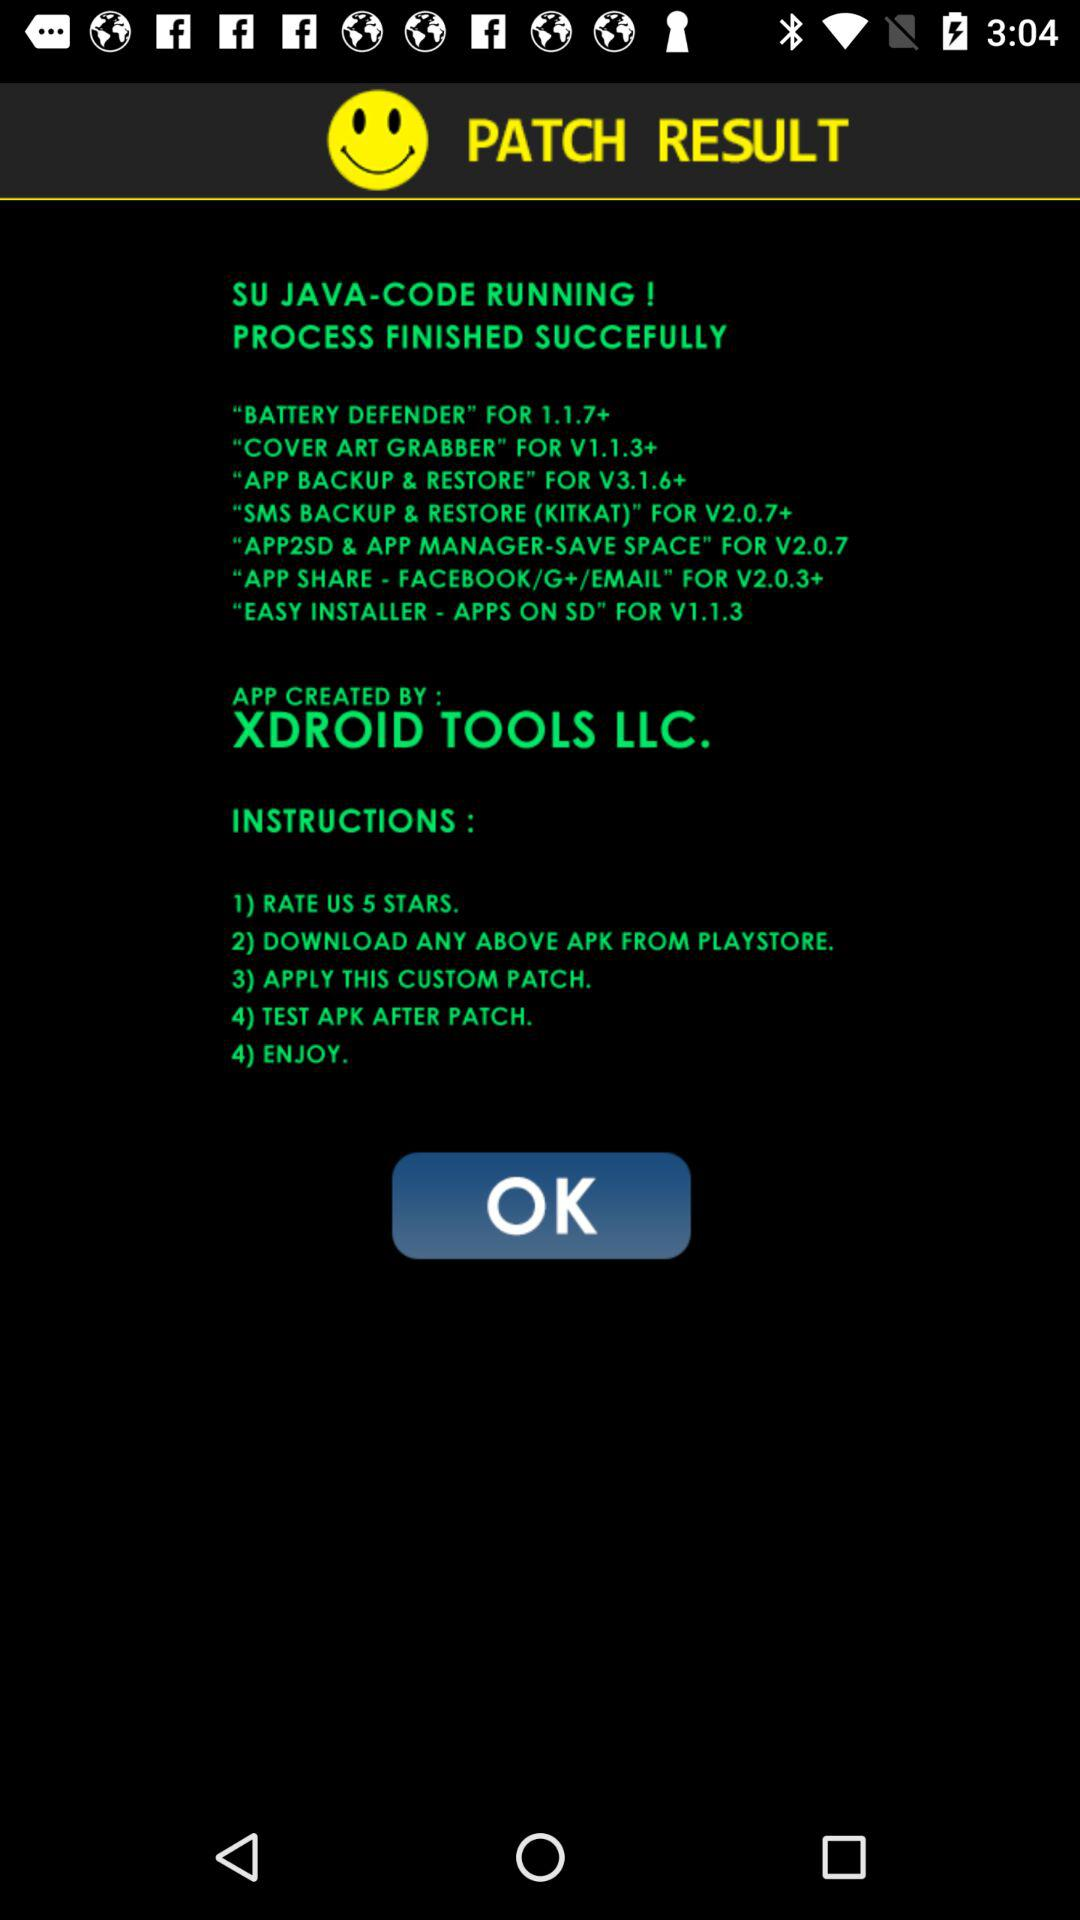How many steps are in the instructions?
Answer the question using a single word or phrase. 4 